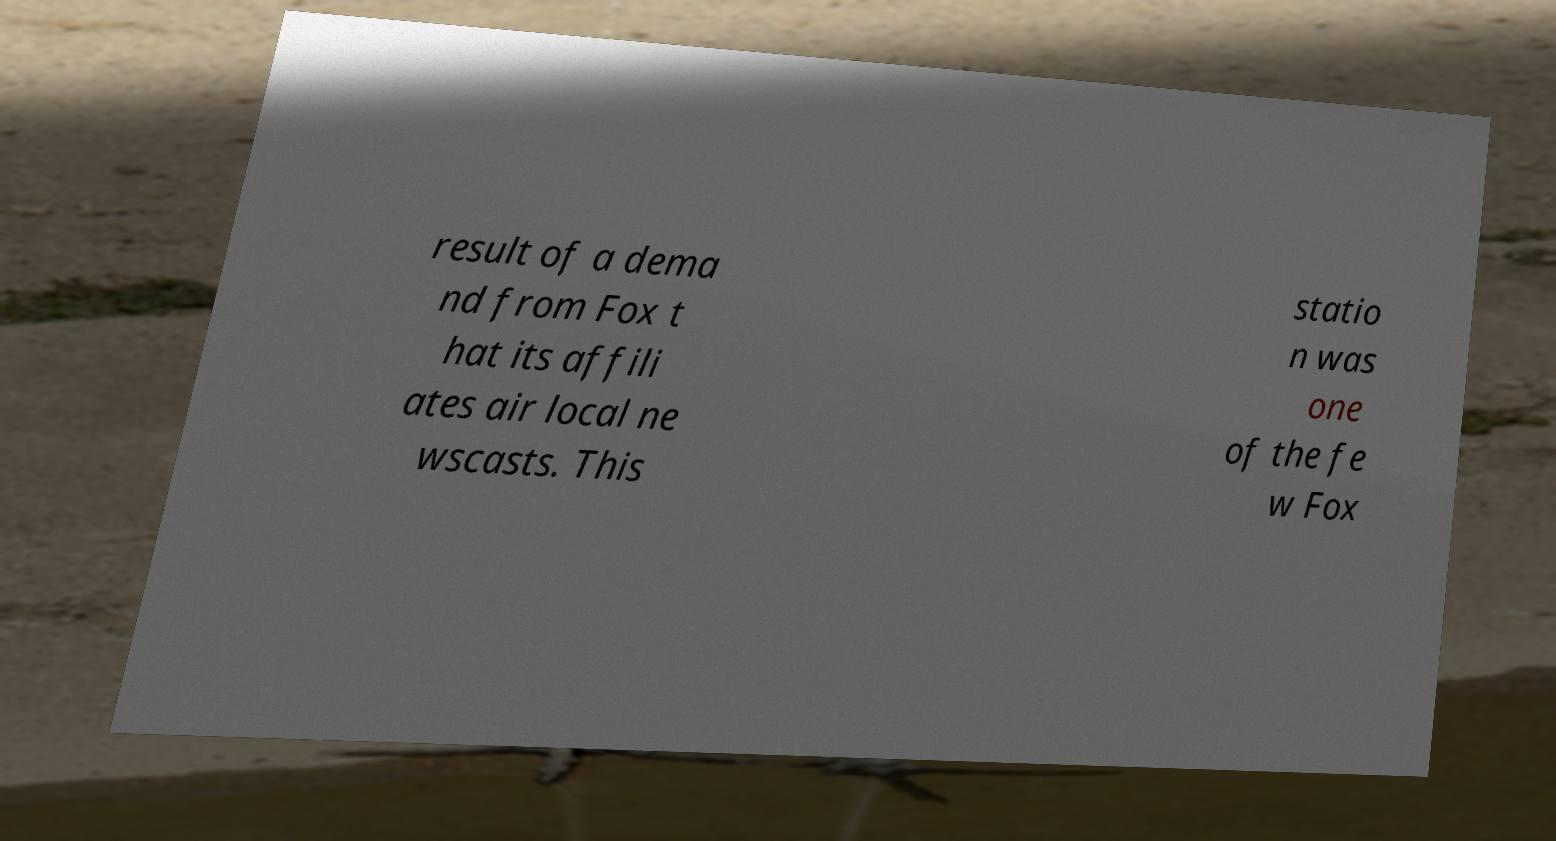What messages or text are displayed in this image? I need them in a readable, typed format. result of a dema nd from Fox t hat its affili ates air local ne wscasts. This statio n was one of the fe w Fox 